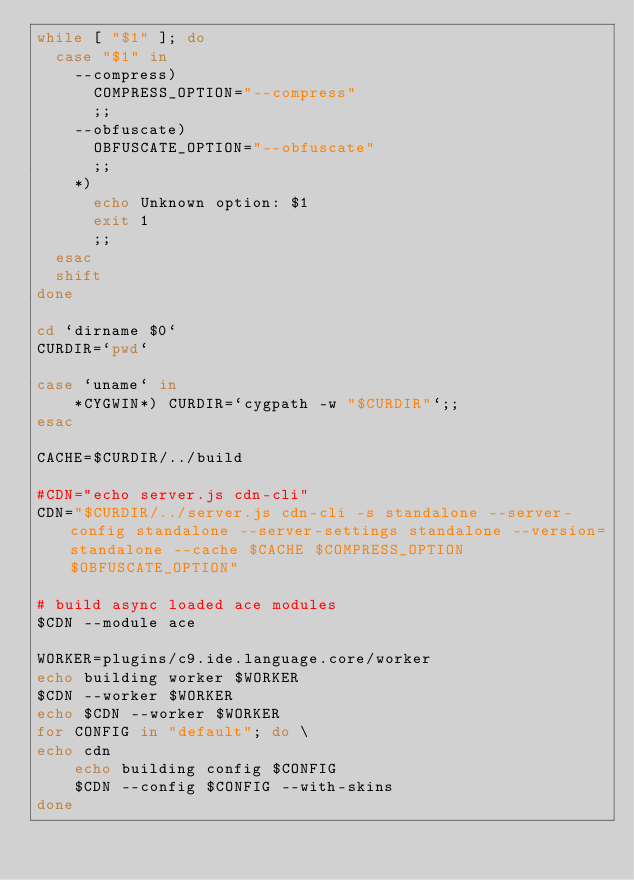<code> <loc_0><loc_0><loc_500><loc_500><_Bash_>while [ "$1" ]; do
  case "$1" in
    --compress)
      COMPRESS_OPTION="--compress"
      ;;
    --obfuscate)
      OBFUSCATE_OPTION="--obfuscate"
      ;;
    *)
      echo Unknown option: $1
      exit 1
      ;;
  esac
  shift
done

cd `dirname $0`
CURDIR=`pwd`

case `uname` in
    *CYGWIN*) CURDIR=`cygpath -w "$CURDIR"`;;
esac

CACHE=$CURDIR/../build

#CDN="echo server.js cdn-cli"
CDN="$CURDIR/../server.js cdn-cli -s standalone --server-config standalone --server-settings standalone --version=standalone --cache $CACHE $COMPRESS_OPTION $OBFUSCATE_OPTION"

# build async loaded ace modules
$CDN --module ace

WORKER=plugins/c9.ide.language.core/worker
echo building worker $WORKER
$CDN --worker $WORKER
echo $CDN --worker $WORKER
for CONFIG in "default"; do \
echo cdn
    echo building config $CONFIG
    $CDN --config $CONFIG --with-skins
done
</code> 